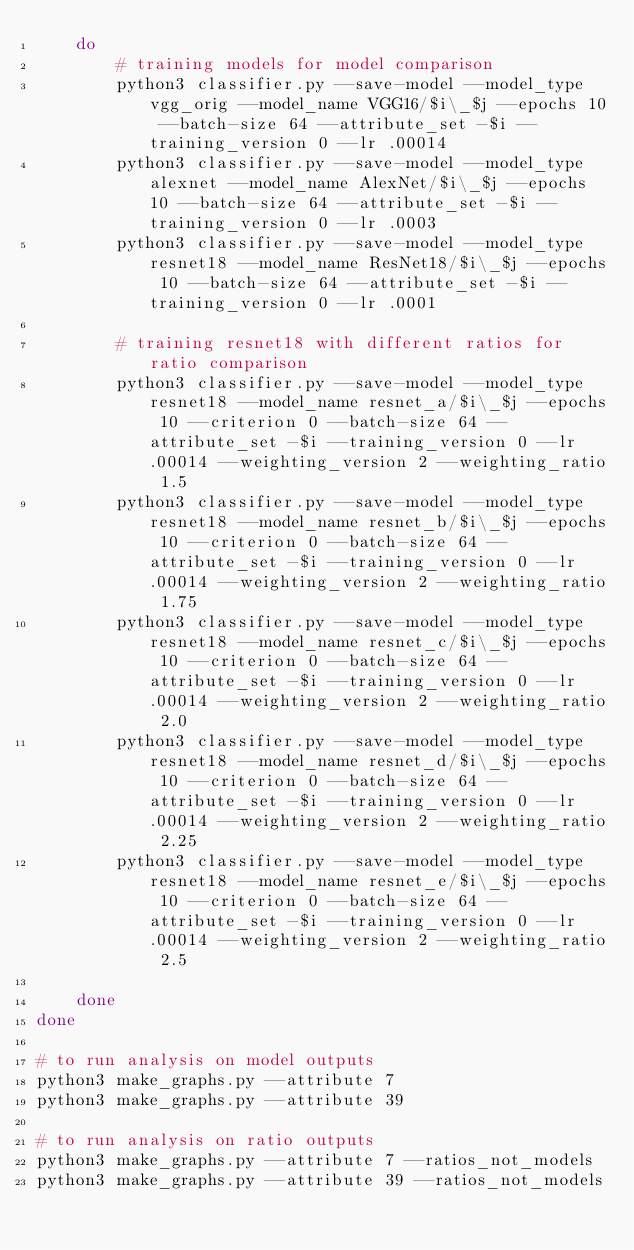<code> <loc_0><loc_0><loc_500><loc_500><_Bash_>    do
        # training models for model comparison
        python3 classifier.py --save-model --model_type vgg_orig --model_name VGG16/$i\_$j --epochs 10 --batch-size 64 --attribute_set -$i --training_version 0 --lr .00014
        python3 classifier.py --save-model --model_type alexnet --model_name AlexNet/$i\_$j --epochs 10 --batch-size 64 --attribute_set -$i --training_version 0 --lr .0003
        python3 classifier.py --save-model --model_type resnet18 --model_name ResNet18/$i\_$j --epochs 10 --batch-size 64 --attribute_set -$i --training_version 0 --lr .0001

        # training resnet18 with different ratios for ratio comparison
        python3 classifier.py --save-model --model_type resnet18 --model_name resnet_a/$i\_$j --epochs 10 --criterion 0 --batch-size 64 --attribute_set -$i --training_version 0 --lr .00014 --weighting_version 2 --weighting_ratio 1.5
        python3 classifier.py --save-model --model_type resnet18 --model_name resnet_b/$i\_$j --epochs 10 --criterion 0 --batch-size 64 --attribute_set -$i --training_version 0 --lr .00014 --weighting_version 2 --weighting_ratio 1.75
        python3 classifier.py --save-model --model_type resnet18 --model_name resnet_c/$i\_$j --epochs 10 --criterion 0 --batch-size 64 --attribute_set -$i --training_version 0 --lr .00014 --weighting_version 2 --weighting_ratio 2.0
        python3 classifier.py --save-model --model_type resnet18 --model_name resnet_d/$i\_$j --epochs 10 --criterion 0 --batch-size 64 --attribute_set -$i --training_version 0 --lr .00014 --weighting_version 2 --weighting_ratio 2.25
        python3 classifier.py --save-model --model_type resnet18 --model_name resnet_e/$i\_$j --epochs 10 --criterion 0 --batch-size 64 --attribute_set -$i --training_version 0 --lr .00014 --weighting_version 2 --weighting_ratio 2.5

    done
done

# to run analysis on model outputs 
python3 make_graphs.py --attribute 7
python3 make_graphs.py --attribute 39

# to run analysis on ratio outputs
python3 make_graphs.py --attribute 7 --ratios_not_models
python3 make_graphs.py --attribute 39 --ratios_not_models
</code> 